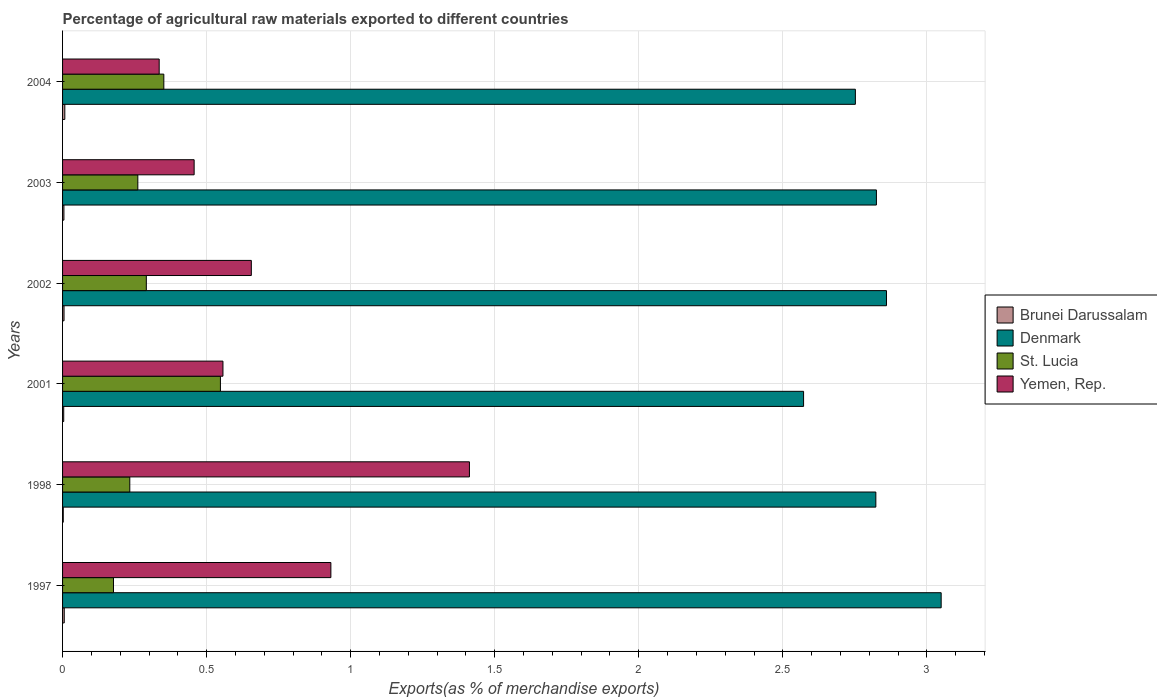How many bars are there on the 3rd tick from the top?
Offer a terse response. 4. What is the label of the 4th group of bars from the top?
Make the answer very short. 2001. In how many cases, is the number of bars for a given year not equal to the number of legend labels?
Provide a succinct answer. 0. What is the percentage of exports to different countries in Yemen, Rep. in 2001?
Your response must be concise. 0.56. Across all years, what is the maximum percentage of exports to different countries in Yemen, Rep.?
Keep it short and to the point. 1.41. Across all years, what is the minimum percentage of exports to different countries in Denmark?
Offer a terse response. 2.57. What is the total percentage of exports to different countries in St. Lucia in the graph?
Ensure brevity in your answer.  1.86. What is the difference between the percentage of exports to different countries in Yemen, Rep. in 1997 and that in 2001?
Ensure brevity in your answer.  0.37. What is the difference between the percentage of exports to different countries in Brunei Darussalam in 2004 and the percentage of exports to different countries in Yemen, Rep. in 1998?
Ensure brevity in your answer.  -1.4. What is the average percentage of exports to different countries in Denmark per year?
Give a very brief answer. 2.81. In the year 2001, what is the difference between the percentage of exports to different countries in Yemen, Rep. and percentage of exports to different countries in St. Lucia?
Offer a terse response. 0.01. What is the ratio of the percentage of exports to different countries in Yemen, Rep. in 2001 to that in 2003?
Give a very brief answer. 1.22. Is the difference between the percentage of exports to different countries in Yemen, Rep. in 1998 and 2003 greater than the difference between the percentage of exports to different countries in St. Lucia in 1998 and 2003?
Your response must be concise. Yes. What is the difference between the highest and the second highest percentage of exports to different countries in Brunei Darussalam?
Offer a terse response. 0. What is the difference between the highest and the lowest percentage of exports to different countries in St. Lucia?
Make the answer very short. 0.37. In how many years, is the percentage of exports to different countries in Denmark greater than the average percentage of exports to different countries in Denmark taken over all years?
Your answer should be very brief. 4. Is it the case that in every year, the sum of the percentage of exports to different countries in Yemen, Rep. and percentage of exports to different countries in Brunei Darussalam is greater than the sum of percentage of exports to different countries in Denmark and percentage of exports to different countries in St. Lucia?
Your answer should be compact. No. What does the 2nd bar from the top in 2004 represents?
Your answer should be compact. St. Lucia. What does the 3rd bar from the bottom in 2003 represents?
Your response must be concise. St. Lucia. Is it the case that in every year, the sum of the percentage of exports to different countries in St. Lucia and percentage of exports to different countries in Denmark is greater than the percentage of exports to different countries in Yemen, Rep.?
Offer a terse response. Yes. Are all the bars in the graph horizontal?
Offer a terse response. Yes. How many years are there in the graph?
Your answer should be compact. 6. Are the values on the major ticks of X-axis written in scientific E-notation?
Your answer should be compact. No. What is the title of the graph?
Offer a very short reply. Percentage of agricultural raw materials exported to different countries. What is the label or title of the X-axis?
Provide a short and direct response. Exports(as % of merchandise exports). What is the label or title of the Y-axis?
Offer a very short reply. Years. What is the Exports(as % of merchandise exports) in Brunei Darussalam in 1997?
Offer a very short reply. 0.01. What is the Exports(as % of merchandise exports) in Denmark in 1997?
Provide a succinct answer. 3.05. What is the Exports(as % of merchandise exports) in St. Lucia in 1997?
Make the answer very short. 0.18. What is the Exports(as % of merchandise exports) in Yemen, Rep. in 1997?
Ensure brevity in your answer.  0.93. What is the Exports(as % of merchandise exports) in Brunei Darussalam in 1998?
Offer a very short reply. 0. What is the Exports(as % of merchandise exports) in Denmark in 1998?
Provide a succinct answer. 2.82. What is the Exports(as % of merchandise exports) in St. Lucia in 1998?
Ensure brevity in your answer.  0.23. What is the Exports(as % of merchandise exports) of Yemen, Rep. in 1998?
Offer a very short reply. 1.41. What is the Exports(as % of merchandise exports) of Brunei Darussalam in 2001?
Provide a short and direct response. 0. What is the Exports(as % of merchandise exports) in Denmark in 2001?
Your answer should be compact. 2.57. What is the Exports(as % of merchandise exports) in St. Lucia in 2001?
Your answer should be very brief. 0.55. What is the Exports(as % of merchandise exports) of Yemen, Rep. in 2001?
Your answer should be compact. 0.56. What is the Exports(as % of merchandise exports) of Brunei Darussalam in 2002?
Ensure brevity in your answer.  0.01. What is the Exports(as % of merchandise exports) in Denmark in 2002?
Your answer should be compact. 2.86. What is the Exports(as % of merchandise exports) of St. Lucia in 2002?
Offer a terse response. 0.29. What is the Exports(as % of merchandise exports) in Yemen, Rep. in 2002?
Give a very brief answer. 0.66. What is the Exports(as % of merchandise exports) of Brunei Darussalam in 2003?
Provide a short and direct response. 0. What is the Exports(as % of merchandise exports) in Denmark in 2003?
Your answer should be compact. 2.82. What is the Exports(as % of merchandise exports) in St. Lucia in 2003?
Your answer should be very brief. 0.26. What is the Exports(as % of merchandise exports) in Yemen, Rep. in 2003?
Provide a short and direct response. 0.46. What is the Exports(as % of merchandise exports) of Brunei Darussalam in 2004?
Offer a terse response. 0.01. What is the Exports(as % of merchandise exports) in Denmark in 2004?
Your response must be concise. 2.75. What is the Exports(as % of merchandise exports) of St. Lucia in 2004?
Your response must be concise. 0.35. What is the Exports(as % of merchandise exports) in Yemen, Rep. in 2004?
Provide a short and direct response. 0.34. Across all years, what is the maximum Exports(as % of merchandise exports) of Brunei Darussalam?
Provide a succinct answer. 0.01. Across all years, what is the maximum Exports(as % of merchandise exports) of Denmark?
Your answer should be very brief. 3.05. Across all years, what is the maximum Exports(as % of merchandise exports) of St. Lucia?
Your answer should be very brief. 0.55. Across all years, what is the maximum Exports(as % of merchandise exports) of Yemen, Rep.?
Keep it short and to the point. 1.41. Across all years, what is the minimum Exports(as % of merchandise exports) of Brunei Darussalam?
Provide a short and direct response. 0. Across all years, what is the minimum Exports(as % of merchandise exports) of Denmark?
Offer a terse response. 2.57. Across all years, what is the minimum Exports(as % of merchandise exports) of St. Lucia?
Make the answer very short. 0.18. Across all years, what is the minimum Exports(as % of merchandise exports) in Yemen, Rep.?
Your response must be concise. 0.34. What is the total Exports(as % of merchandise exports) of Brunei Darussalam in the graph?
Offer a terse response. 0.03. What is the total Exports(as % of merchandise exports) in Denmark in the graph?
Make the answer very short. 16.88. What is the total Exports(as % of merchandise exports) of St. Lucia in the graph?
Provide a succinct answer. 1.86. What is the total Exports(as % of merchandise exports) of Yemen, Rep. in the graph?
Offer a very short reply. 4.35. What is the difference between the Exports(as % of merchandise exports) of Brunei Darussalam in 1997 and that in 1998?
Offer a very short reply. 0. What is the difference between the Exports(as % of merchandise exports) in Denmark in 1997 and that in 1998?
Provide a short and direct response. 0.23. What is the difference between the Exports(as % of merchandise exports) in St. Lucia in 1997 and that in 1998?
Your answer should be compact. -0.06. What is the difference between the Exports(as % of merchandise exports) in Yemen, Rep. in 1997 and that in 1998?
Make the answer very short. -0.48. What is the difference between the Exports(as % of merchandise exports) of Brunei Darussalam in 1997 and that in 2001?
Offer a very short reply. 0. What is the difference between the Exports(as % of merchandise exports) of Denmark in 1997 and that in 2001?
Ensure brevity in your answer.  0.48. What is the difference between the Exports(as % of merchandise exports) in St. Lucia in 1997 and that in 2001?
Ensure brevity in your answer.  -0.37. What is the difference between the Exports(as % of merchandise exports) in Yemen, Rep. in 1997 and that in 2001?
Give a very brief answer. 0.37. What is the difference between the Exports(as % of merchandise exports) in Brunei Darussalam in 1997 and that in 2002?
Your response must be concise. 0. What is the difference between the Exports(as % of merchandise exports) of Denmark in 1997 and that in 2002?
Your answer should be compact. 0.19. What is the difference between the Exports(as % of merchandise exports) in St. Lucia in 1997 and that in 2002?
Your answer should be compact. -0.11. What is the difference between the Exports(as % of merchandise exports) in Yemen, Rep. in 1997 and that in 2002?
Offer a very short reply. 0.28. What is the difference between the Exports(as % of merchandise exports) of Brunei Darussalam in 1997 and that in 2003?
Ensure brevity in your answer.  0. What is the difference between the Exports(as % of merchandise exports) in Denmark in 1997 and that in 2003?
Your response must be concise. 0.22. What is the difference between the Exports(as % of merchandise exports) of St. Lucia in 1997 and that in 2003?
Offer a terse response. -0.08. What is the difference between the Exports(as % of merchandise exports) in Yemen, Rep. in 1997 and that in 2003?
Make the answer very short. 0.47. What is the difference between the Exports(as % of merchandise exports) of Brunei Darussalam in 1997 and that in 2004?
Provide a succinct answer. -0. What is the difference between the Exports(as % of merchandise exports) in Denmark in 1997 and that in 2004?
Make the answer very short. 0.3. What is the difference between the Exports(as % of merchandise exports) of St. Lucia in 1997 and that in 2004?
Offer a terse response. -0.17. What is the difference between the Exports(as % of merchandise exports) of Yemen, Rep. in 1997 and that in 2004?
Your answer should be very brief. 0.6. What is the difference between the Exports(as % of merchandise exports) of Brunei Darussalam in 1998 and that in 2001?
Keep it short and to the point. -0. What is the difference between the Exports(as % of merchandise exports) of Denmark in 1998 and that in 2001?
Keep it short and to the point. 0.25. What is the difference between the Exports(as % of merchandise exports) of St. Lucia in 1998 and that in 2001?
Your answer should be very brief. -0.31. What is the difference between the Exports(as % of merchandise exports) in Yemen, Rep. in 1998 and that in 2001?
Your answer should be very brief. 0.86. What is the difference between the Exports(as % of merchandise exports) in Brunei Darussalam in 1998 and that in 2002?
Your answer should be very brief. -0. What is the difference between the Exports(as % of merchandise exports) of Denmark in 1998 and that in 2002?
Provide a succinct answer. -0.04. What is the difference between the Exports(as % of merchandise exports) in St. Lucia in 1998 and that in 2002?
Offer a very short reply. -0.06. What is the difference between the Exports(as % of merchandise exports) of Yemen, Rep. in 1998 and that in 2002?
Provide a short and direct response. 0.76. What is the difference between the Exports(as % of merchandise exports) in Brunei Darussalam in 1998 and that in 2003?
Your answer should be compact. -0. What is the difference between the Exports(as % of merchandise exports) of Denmark in 1998 and that in 2003?
Ensure brevity in your answer.  -0. What is the difference between the Exports(as % of merchandise exports) of St. Lucia in 1998 and that in 2003?
Provide a short and direct response. -0.03. What is the difference between the Exports(as % of merchandise exports) of Yemen, Rep. in 1998 and that in 2003?
Your response must be concise. 0.96. What is the difference between the Exports(as % of merchandise exports) in Brunei Darussalam in 1998 and that in 2004?
Your response must be concise. -0.01. What is the difference between the Exports(as % of merchandise exports) in Denmark in 1998 and that in 2004?
Keep it short and to the point. 0.07. What is the difference between the Exports(as % of merchandise exports) in St. Lucia in 1998 and that in 2004?
Ensure brevity in your answer.  -0.12. What is the difference between the Exports(as % of merchandise exports) of Brunei Darussalam in 2001 and that in 2002?
Offer a very short reply. -0. What is the difference between the Exports(as % of merchandise exports) of Denmark in 2001 and that in 2002?
Provide a succinct answer. -0.29. What is the difference between the Exports(as % of merchandise exports) of St. Lucia in 2001 and that in 2002?
Offer a very short reply. 0.26. What is the difference between the Exports(as % of merchandise exports) of Yemen, Rep. in 2001 and that in 2002?
Provide a short and direct response. -0.1. What is the difference between the Exports(as % of merchandise exports) of Brunei Darussalam in 2001 and that in 2003?
Your answer should be very brief. -0. What is the difference between the Exports(as % of merchandise exports) in Denmark in 2001 and that in 2003?
Your response must be concise. -0.25. What is the difference between the Exports(as % of merchandise exports) in St. Lucia in 2001 and that in 2003?
Make the answer very short. 0.29. What is the difference between the Exports(as % of merchandise exports) in Yemen, Rep. in 2001 and that in 2003?
Keep it short and to the point. 0.1. What is the difference between the Exports(as % of merchandise exports) of Brunei Darussalam in 2001 and that in 2004?
Offer a very short reply. -0. What is the difference between the Exports(as % of merchandise exports) of Denmark in 2001 and that in 2004?
Ensure brevity in your answer.  -0.18. What is the difference between the Exports(as % of merchandise exports) in St. Lucia in 2001 and that in 2004?
Your answer should be very brief. 0.2. What is the difference between the Exports(as % of merchandise exports) of Yemen, Rep. in 2001 and that in 2004?
Make the answer very short. 0.22. What is the difference between the Exports(as % of merchandise exports) of Denmark in 2002 and that in 2003?
Your answer should be compact. 0.03. What is the difference between the Exports(as % of merchandise exports) of St. Lucia in 2002 and that in 2003?
Ensure brevity in your answer.  0.03. What is the difference between the Exports(as % of merchandise exports) in Yemen, Rep. in 2002 and that in 2003?
Provide a succinct answer. 0.2. What is the difference between the Exports(as % of merchandise exports) in Brunei Darussalam in 2002 and that in 2004?
Your answer should be compact. -0. What is the difference between the Exports(as % of merchandise exports) of Denmark in 2002 and that in 2004?
Your answer should be very brief. 0.11. What is the difference between the Exports(as % of merchandise exports) of St. Lucia in 2002 and that in 2004?
Provide a short and direct response. -0.06. What is the difference between the Exports(as % of merchandise exports) in Yemen, Rep. in 2002 and that in 2004?
Offer a terse response. 0.32. What is the difference between the Exports(as % of merchandise exports) of Brunei Darussalam in 2003 and that in 2004?
Offer a terse response. -0. What is the difference between the Exports(as % of merchandise exports) of Denmark in 2003 and that in 2004?
Your response must be concise. 0.07. What is the difference between the Exports(as % of merchandise exports) in St. Lucia in 2003 and that in 2004?
Keep it short and to the point. -0.09. What is the difference between the Exports(as % of merchandise exports) of Yemen, Rep. in 2003 and that in 2004?
Your answer should be compact. 0.12. What is the difference between the Exports(as % of merchandise exports) in Brunei Darussalam in 1997 and the Exports(as % of merchandise exports) in Denmark in 1998?
Give a very brief answer. -2.82. What is the difference between the Exports(as % of merchandise exports) of Brunei Darussalam in 1997 and the Exports(as % of merchandise exports) of St. Lucia in 1998?
Offer a terse response. -0.23. What is the difference between the Exports(as % of merchandise exports) in Brunei Darussalam in 1997 and the Exports(as % of merchandise exports) in Yemen, Rep. in 1998?
Your answer should be compact. -1.41. What is the difference between the Exports(as % of merchandise exports) of Denmark in 1997 and the Exports(as % of merchandise exports) of St. Lucia in 1998?
Offer a terse response. 2.82. What is the difference between the Exports(as % of merchandise exports) of Denmark in 1997 and the Exports(as % of merchandise exports) of Yemen, Rep. in 1998?
Your answer should be compact. 1.64. What is the difference between the Exports(as % of merchandise exports) of St. Lucia in 1997 and the Exports(as % of merchandise exports) of Yemen, Rep. in 1998?
Your answer should be compact. -1.24. What is the difference between the Exports(as % of merchandise exports) in Brunei Darussalam in 1997 and the Exports(as % of merchandise exports) in Denmark in 2001?
Make the answer very short. -2.57. What is the difference between the Exports(as % of merchandise exports) of Brunei Darussalam in 1997 and the Exports(as % of merchandise exports) of St. Lucia in 2001?
Ensure brevity in your answer.  -0.54. What is the difference between the Exports(as % of merchandise exports) of Brunei Darussalam in 1997 and the Exports(as % of merchandise exports) of Yemen, Rep. in 2001?
Ensure brevity in your answer.  -0.55. What is the difference between the Exports(as % of merchandise exports) of Denmark in 1997 and the Exports(as % of merchandise exports) of St. Lucia in 2001?
Your answer should be very brief. 2.5. What is the difference between the Exports(as % of merchandise exports) in Denmark in 1997 and the Exports(as % of merchandise exports) in Yemen, Rep. in 2001?
Ensure brevity in your answer.  2.49. What is the difference between the Exports(as % of merchandise exports) of St. Lucia in 1997 and the Exports(as % of merchandise exports) of Yemen, Rep. in 2001?
Provide a succinct answer. -0.38. What is the difference between the Exports(as % of merchandise exports) in Brunei Darussalam in 1997 and the Exports(as % of merchandise exports) in Denmark in 2002?
Provide a short and direct response. -2.85. What is the difference between the Exports(as % of merchandise exports) of Brunei Darussalam in 1997 and the Exports(as % of merchandise exports) of St. Lucia in 2002?
Give a very brief answer. -0.28. What is the difference between the Exports(as % of merchandise exports) of Brunei Darussalam in 1997 and the Exports(as % of merchandise exports) of Yemen, Rep. in 2002?
Ensure brevity in your answer.  -0.65. What is the difference between the Exports(as % of merchandise exports) in Denmark in 1997 and the Exports(as % of merchandise exports) in St. Lucia in 2002?
Ensure brevity in your answer.  2.76. What is the difference between the Exports(as % of merchandise exports) in Denmark in 1997 and the Exports(as % of merchandise exports) in Yemen, Rep. in 2002?
Offer a terse response. 2.39. What is the difference between the Exports(as % of merchandise exports) in St. Lucia in 1997 and the Exports(as % of merchandise exports) in Yemen, Rep. in 2002?
Provide a succinct answer. -0.48. What is the difference between the Exports(as % of merchandise exports) in Brunei Darussalam in 1997 and the Exports(as % of merchandise exports) in Denmark in 2003?
Offer a terse response. -2.82. What is the difference between the Exports(as % of merchandise exports) of Brunei Darussalam in 1997 and the Exports(as % of merchandise exports) of St. Lucia in 2003?
Offer a very short reply. -0.26. What is the difference between the Exports(as % of merchandise exports) of Brunei Darussalam in 1997 and the Exports(as % of merchandise exports) of Yemen, Rep. in 2003?
Give a very brief answer. -0.45. What is the difference between the Exports(as % of merchandise exports) in Denmark in 1997 and the Exports(as % of merchandise exports) in St. Lucia in 2003?
Offer a very short reply. 2.79. What is the difference between the Exports(as % of merchandise exports) in Denmark in 1997 and the Exports(as % of merchandise exports) in Yemen, Rep. in 2003?
Your answer should be compact. 2.59. What is the difference between the Exports(as % of merchandise exports) in St. Lucia in 1997 and the Exports(as % of merchandise exports) in Yemen, Rep. in 2003?
Give a very brief answer. -0.28. What is the difference between the Exports(as % of merchandise exports) in Brunei Darussalam in 1997 and the Exports(as % of merchandise exports) in Denmark in 2004?
Keep it short and to the point. -2.75. What is the difference between the Exports(as % of merchandise exports) in Brunei Darussalam in 1997 and the Exports(as % of merchandise exports) in St. Lucia in 2004?
Your answer should be very brief. -0.35. What is the difference between the Exports(as % of merchandise exports) in Brunei Darussalam in 1997 and the Exports(as % of merchandise exports) in Yemen, Rep. in 2004?
Offer a terse response. -0.33. What is the difference between the Exports(as % of merchandise exports) of Denmark in 1997 and the Exports(as % of merchandise exports) of St. Lucia in 2004?
Provide a succinct answer. 2.7. What is the difference between the Exports(as % of merchandise exports) of Denmark in 1997 and the Exports(as % of merchandise exports) of Yemen, Rep. in 2004?
Make the answer very short. 2.71. What is the difference between the Exports(as % of merchandise exports) of St. Lucia in 1997 and the Exports(as % of merchandise exports) of Yemen, Rep. in 2004?
Your answer should be very brief. -0.16. What is the difference between the Exports(as % of merchandise exports) in Brunei Darussalam in 1998 and the Exports(as % of merchandise exports) in Denmark in 2001?
Provide a short and direct response. -2.57. What is the difference between the Exports(as % of merchandise exports) in Brunei Darussalam in 1998 and the Exports(as % of merchandise exports) in St. Lucia in 2001?
Offer a terse response. -0.55. What is the difference between the Exports(as % of merchandise exports) of Brunei Darussalam in 1998 and the Exports(as % of merchandise exports) of Yemen, Rep. in 2001?
Provide a succinct answer. -0.55. What is the difference between the Exports(as % of merchandise exports) of Denmark in 1998 and the Exports(as % of merchandise exports) of St. Lucia in 2001?
Ensure brevity in your answer.  2.27. What is the difference between the Exports(as % of merchandise exports) of Denmark in 1998 and the Exports(as % of merchandise exports) of Yemen, Rep. in 2001?
Offer a very short reply. 2.27. What is the difference between the Exports(as % of merchandise exports) of St. Lucia in 1998 and the Exports(as % of merchandise exports) of Yemen, Rep. in 2001?
Your response must be concise. -0.32. What is the difference between the Exports(as % of merchandise exports) in Brunei Darussalam in 1998 and the Exports(as % of merchandise exports) in Denmark in 2002?
Provide a succinct answer. -2.86. What is the difference between the Exports(as % of merchandise exports) of Brunei Darussalam in 1998 and the Exports(as % of merchandise exports) of St. Lucia in 2002?
Keep it short and to the point. -0.29. What is the difference between the Exports(as % of merchandise exports) of Brunei Darussalam in 1998 and the Exports(as % of merchandise exports) of Yemen, Rep. in 2002?
Give a very brief answer. -0.65. What is the difference between the Exports(as % of merchandise exports) of Denmark in 1998 and the Exports(as % of merchandise exports) of St. Lucia in 2002?
Your answer should be very brief. 2.53. What is the difference between the Exports(as % of merchandise exports) of Denmark in 1998 and the Exports(as % of merchandise exports) of Yemen, Rep. in 2002?
Offer a very short reply. 2.17. What is the difference between the Exports(as % of merchandise exports) in St. Lucia in 1998 and the Exports(as % of merchandise exports) in Yemen, Rep. in 2002?
Your answer should be very brief. -0.42. What is the difference between the Exports(as % of merchandise exports) in Brunei Darussalam in 1998 and the Exports(as % of merchandise exports) in Denmark in 2003?
Provide a succinct answer. -2.82. What is the difference between the Exports(as % of merchandise exports) in Brunei Darussalam in 1998 and the Exports(as % of merchandise exports) in St. Lucia in 2003?
Offer a terse response. -0.26. What is the difference between the Exports(as % of merchandise exports) in Brunei Darussalam in 1998 and the Exports(as % of merchandise exports) in Yemen, Rep. in 2003?
Make the answer very short. -0.45. What is the difference between the Exports(as % of merchandise exports) of Denmark in 1998 and the Exports(as % of merchandise exports) of St. Lucia in 2003?
Your response must be concise. 2.56. What is the difference between the Exports(as % of merchandise exports) in Denmark in 1998 and the Exports(as % of merchandise exports) in Yemen, Rep. in 2003?
Keep it short and to the point. 2.37. What is the difference between the Exports(as % of merchandise exports) of St. Lucia in 1998 and the Exports(as % of merchandise exports) of Yemen, Rep. in 2003?
Your answer should be very brief. -0.22. What is the difference between the Exports(as % of merchandise exports) of Brunei Darussalam in 1998 and the Exports(as % of merchandise exports) of Denmark in 2004?
Keep it short and to the point. -2.75. What is the difference between the Exports(as % of merchandise exports) of Brunei Darussalam in 1998 and the Exports(as % of merchandise exports) of St. Lucia in 2004?
Offer a terse response. -0.35. What is the difference between the Exports(as % of merchandise exports) in Brunei Darussalam in 1998 and the Exports(as % of merchandise exports) in Yemen, Rep. in 2004?
Your answer should be very brief. -0.33. What is the difference between the Exports(as % of merchandise exports) in Denmark in 1998 and the Exports(as % of merchandise exports) in St. Lucia in 2004?
Give a very brief answer. 2.47. What is the difference between the Exports(as % of merchandise exports) in Denmark in 1998 and the Exports(as % of merchandise exports) in Yemen, Rep. in 2004?
Offer a very short reply. 2.49. What is the difference between the Exports(as % of merchandise exports) of St. Lucia in 1998 and the Exports(as % of merchandise exports) of Yemen, Rep. in 2004?
Your answer should be very brief. -0.1. What is the difference between the Exports(as % of merchandise exports) of Brunei Darussalam in 2001 and the Exports(as % of merchandise exports) of Denmark in 2002?
Make the answer very short. -2.86. What is the difference between the Exports(as % of merchandise exports) in Brunei Darussalam in 2001 and the Exports(as % of merchandise exports) in St. Lucia in 2002?
Give a very brief answer. -0.29. What is the difference between the Exports(as % of merchandise exports) of Brunei Darussalam in 2001 and the Exports(as % of merchandise exports) of Yemen, Rep. in 2002?
Keep it short and to the point. -0.65. What is the difference between the Exports(as % of merchandise exports) in Denmark in 2001 and the Exports(as % of merchandise exports) in St. Lucia in 2002?
Give a very brief answer. 2.28. What is the difference between the Exports(as % of merchandise exports) of Denmark in 2001 and the Exports(as % of merchandise exports) of Yemen, Rep. in 2002?
Keep it short and to the point. 1.92. What is the difference between the Exports(as % of merchandise exports) of St. Lucia in 2001 and the Exports(as % of merchandise exports) of Yemen, Rep. in 2002?
Provide a short and direct response. -0.11. What is the difference between the Exports(as % of merchandise exports) of Brunei Darussalam in 2001 and the Exports(as % of merchandise exports) of Denmark in 2003?
Make the answer very short. -2.82. What is the difference between the Exports(as % of merchandise exports) of Brunei Darussalam in 2001 and the Exports(as % of merchandise exports) of St. Lucia in 2003?
Make the answer very short. -0.26. What is the difference between the Exports(as % of merchandise exports) of Brunei Darussalam in 2001 and the Exports(as % of merchandise exports) of Yemen, Rep. in 2003?
Offer a terse response. -0.45. What is the difference between the Exports(as % of merchandise exports) in Denmark in 2001 and the Exports(as % of merchandise exports) in St. Lucia in 2003?
Your answer should be very brief. 2.31. What is the difference between the Exports(as % of merchandise exports) in Denmark in 2001 and the Exports(as % of merchandise exports) in Yemen, Rep. in 2003?
Make the answer very short. 2.12. What is the difference between the Exports(as % of merchandise exports) of St. Lucia in 2001 and the Exports(as % of merchandise exports) of Yemen, Rep. in 2003?
Provide a short and direct response. 0.09. What is the difference between the Exports(as % of merchandise exports) of Brunei Darussalam in 2001 and the Exports(as % of merchandise exports) of Denmark in 2004?
Offer a terse response. -2.75. What is the difference between the Exports(as % of merchandise exports) in Brunei Darussalam in 2001 and the Exports(as % of merchandise exports) in St. Lucia in 2004?
Ensure brevity in your answer.  -0.35. What is the difference between the Exports(as % of merchandise exports) of Brunei Darussalam in 2001 and the Exports(as % of merchandise exports) of Yemen, Rep. in 2004?
Your answer should be compact. -0.33. What is the difference between the Exports(as % of merchandise exports) in Denmark in 2001 and the Exports(as % of merchandise exports) in St. Lucia in 2004?
Your answer should be very brief. 2.22. What is the difference between the Exports(as % of merchandise exports) in Denmark in 2001 and the Exports(as % of merchandise exports) in Yemen, Rep. in 2004?
Your answer should be very brief. 2.24. What is the difference between the Exports(as % of merchandise exports) of St. Lucia in 2001 and the Exports(as % of merchandise exports) of Yemen, Rep. in 2004?
Ensure brevity in your answer.  0.21. What is the difference between the Exports(as % of merchandise exports) in Brunei Darussalam in 2002 and the Exports(as % of merchandise exports) in Denmark in 2003?
Your answer should be very brief. -2.82. What is the difference between the Exports(as % of merchandise exports) in Brunei Darussalam in 2002 and the Exports(as % of merchandise exports) in St. Lucia in 2003?
Provide a succinct answer. -0.26. What is the difference between the Exports(as % of merchandise exports) in Brunei Darussalam in 2002 and the Exports(as % of merchandise exports) in Yemen, Rep. in 2003?
Provide a succinct answer. -0.45. What is the difference between the Exports(as % of merchandise exports) in Denmark in 2002 and the Exports(as % of merchandise exports) in St. Lucia in 2003?
Give a very brief answer. 2.6. What is the difference between the Exports(as % of merchandise exports) of Denmark in 2002 and the Exports(as % of merchandise exports) of Yemen, Rep. in 2003?
Your response must be concise. 2.4. What is the difference between the Exports(as % of merchandise exports) in St. Lucia in 2002 and the Exports(as % of merchandise exports) in Yemen, Rep. in 2003?
Give a very brief answer. -0.17. What is the difference between the Exports(as % of merchandise exports) of Brunei Darussalam in 2002 and the Exports(as % of merchandise exports) of Denmark in 2004?
Provide a succinct answer. -2.75. What is the difference between the Exports(as % of merchandise exports) in Brunei Darussalam in 2002 and the Exports(as % of merchandise exports) in St. Lucia in 2004?
Provide a short and direct response. -0.35. What is the difference between the Exports(as % of merchandise exports) in Brunei Darussalam in 2002 and the Exports(as % of merchandise exports) in Yemen, Rep. in 2004?
Offer a very short reply. -0.33. What is the difference between the Exports(as % of merchandise exports) in Denmark in 2002 and the Exports(as % of merchandise exports) in St. Lucia in 2004?
Your answer should be compact. 2.51. What is the difference between the Exports(as % of merchandise exports) in Denmark in 2002 and the Exports(as % of merchandise exports) in Yemen, Rep. in 2004?
Give a very brief answer. 2.52. What is the difference between the Exports(as % of merchandise exports) in St. Lucia in 2002 and the Exports(as % of merchandise exports) in Yemen, Rep. in 2004?
Make the answer very short. -0.04. What is the difference between the Exports(as % of merchandise exports) of Brunei Darussalam in 2003 and the Exports(as % of merchandise exports) of Denmark in 2004?
Offer a very short reply. -2.75. What is the difference between the Exports(as % of merchandise exports) in Brunei Darussalam in 2003 and the Exports(as % of merchandise exports) in St. Lucia in 2004?
Ensure brevity in your answer.  -0.35. What is the difference between the Exports(as % of merchandise exports) of Brunei Darussalam in 2003 and the Exports(as % of merchandise exports) of Yemen, Rep. in 2004?
Ensure brevity in your answer.  -0.33. What is the difference between the Exports(as % of merchandise exports) in Denmark in 2003 and the Exports(as % of merchandise exports) in St. Lucia in 2004?
Your answer should be very brief. 2.47. What is the difference between the Exports(as % of merchandise exports) in Denmark in 2003 and the Exports(as % of merchandise exports) in Yemen, Rep. in 2004?
Offer a very short reply. 2.49. What is the difference between the Exports(as % of merchandise exports) in St. Lucia in 2003 and the Exports(as % of merchandise exports) in Yemen, Rep. in 2004?
Provide a short and direct response. -0.07. What is the average Exports(as % of merchandise exports) in Brunei Darussalam per year?
Make the answer very short. 0.01. What is the average Exports(as % of merchandise exports) in Denmark per year?
Give a very brief answer. 2.81. What is the average Exports(as % of merchandise exports) of St. Lucia per year?
Provide a short and direct response. 0.31. What is the average Exports(as % of merchandise exports) in Yemen, Rep. per year?
Provide a short and direct response. 0.72. In the year 1997, what is the difference between the Exports(as % of merchandise exports) of Brunei Darussalam and Exports(as % of merchandise exports) of Denmark?
Offer a very short reply. -3.04. In the year 1997, what is the difference between the Exports(as % of merchandise exports) in Brunei Darussalam and Exports(as % of merchandise exports) in St. Lucia?
Provide a short and direct response. -0.17. In the year 1997, what is the difference between the Exports(as % of merchandise exports) of Brunei Darussalam and Exports(as % of merchandise exports) of Yemen, Rep.?
Provide a succinct answer. -0.93. In the year 1997, what is the difference between the Exports(as % of merchandise exports) in Denmark and Exports(as % of merchandise exports) in St. Lucia?
Give a very brief answer. 2.87. In the year 1997, what is the difference between the Exports(as % of merchandise exports) of Denmark and Exports(as % of merchandise exports) of Yemen, Rep.?
Ensure brevity in your answer.  2.12. In the year 1997, what is the difference between the Exports(as % of merchandise exports) of St. Lucia and Exports(as % of merchandise exports) of Yemen, Rep.?
Give a very brief answer. -0.75. In the year 1998, what is the difference between the Exports(as % of merchandise exports) of Brunei Darussalam and Exports(as % of merchandise exports) of Denmark?
Your response must be concise. -2.82. In the year 1998, what is the difference between the Exports(as % of merchandise exports) of Brunei Darussalam and Exports(as % of merchandise exports) of St. Lucia?
Provide a succinct answer. -0.23. In the year 1998, what is the difference between the Exports(as % of merchandise exports) in Brunei Darussalam and Exports(as % of merchandise exports) in Yemen, Rep.?
Ensure brevity in your answer.  -1.41. In the year 1998, what is the difference between the Exports(as % of merchandise exports) of Denmark and Exports(as % of merchandise exports) of St. Lucia?
Provide a succinct answer. 2.59. In the year 1998, what is the difference between the Exports(as % of merchandise exports) of Denmark and Exports(as % of merchandise exports) of Yemen, Rep.?
Offer a very short reply. 1.41. In the year 1998, what is the difference between the Exports(as % of merchandise exports) in St. Lucia and Exports(as % of merchandise exports) in Yemen, Rep.?
Give a very brief answer. -1.18. In the year 2001, what is the difference between the Exports(as % of merchandise exports) in Brunei Darussalam and Exports(as % of merchandise exports) in Denmark?
Ensure brevity in your answer.  -2.57. In the year 2001, what is the difference between the Exports(as % of merchandise exports) of Brunei Darussalam and Exports(as % of merchandise exports) of St. Lucia?
Your answer should be very brief. -0.54. In the year 2001, what is the difference between the Exports(as % of merchandise exports) of Brunei Darussalam and Exports(as % of merchandise exports) of Yemen, Rep.?
Offer a very short reply. -0.55. In the year 2001, what is the difference between the Exports(as % of merchandise exports) of Denmark and Exports(as % of merchandise exports) of St. Lucia?
Provide a short and direct response. 2.02. In the year 2001, what is the difference between the Exports(as % of merchandise exports) of Denmark and Exports(as % of merchandise exports) of Yemen, Rep.?
Ensure brevity in your answer.  2.02. In the year 2001, what is the difference between the Exports(as % of merchandise exports) in St. Lucia and Exports(as % of merchandise exports) in Yemen, Rep.?
Your answer should be very brief. -0.01. In the year 2002, what is the difference between the Exports(as % of merchandise exports) of Brunei Darussalam and Exports(as % of merchandise exports) of Denmark?
Your answer should be very brief. -2.85. In the year 2002, what is the difference between the Exports(as % of merchandise exports) in Brunei Darussalam and Exports(as % of merchandise exports) in St. Lucia?
Provide a short and direct response. -0.29. In the year 2002, what is the difference between the Exports(as % of merchandise exports) in Brunei Darussalam and Exports(as % of merchandise exports) in Yemen, Rep.?
Your answer should be compact. -0.65. In the year 2002, what is the difference between the Exports(as % of merchandise exports) in Denmark and Exports(as % of merchandise exports) in St. Lucia?
Make the answer very short. 2.57. In the year 2002, what is the difference between the Exports(as % of merchandise exports) in Denmark and Exports(as % of merchandise exports) in Yemen, Rep.?
Your response must be concise. 2.2. In the year 2002, what is the difference between the Exports(as % of merchandise exports) of St. Lucia and Exports(as % of merchandise exports) of Yemen, Rep.?
Offer a terse response. -0.36. In the year 2003, what is the difference between the Exports(as % of merchandise exports) of Brunei Darussalam and Exports(as % of merchandise exports) of Denmark?
Keep it short and to the point. -2.82. In the year 2003, what is the difference between the Exports(as % of merchandise exports) of Brunei Darussalam and Exports(as % of merchandise exports) of St. Lucia?
Offer a very short reply. -0.26. In the year 2003, what is the difference between the Exports(as % of merchandise exports) of Brunei Darussalam and Exports(as % of merchandise exports) of Yemen, Rep.?
Ensure brevity in your answer.  -0.45. In the year 2003, what is the difference between the Exports(as % of merchandise exports) of Denmark and Exports(as % of merchandise exports) of St. Lucia?
Keep it short and to the point. 2.56. In the year 2003, what is the difference between the Exports(as % of merchandise exports) of Denmark and Exports(as % of merchandise exports) of Yemen, Rep.?
Your answer should be very brief. 2.37. In the year 2003, what is the difference between the Exports(as % of merchandise exports) in St. Lucia and Exports(as % of merchandise exports) in Yemen, Rep.?
Give a very brief answer. -0.2. In the year 2004, what is the difference between the Exports(as % of merchandise exports) in Brunei Darussalam and Exports(as % of merchandise exports) in Denmark?
Provide a short and direct response. -2.74. In the year 2004, what is the difference between the Exports(as % of merchandise exports) in Brunei Darussalam and Exports(as % of merchandise exports) in St. Lucia?
Offer a terse response. -0.34. In the year 2004, what is the difference between the Exports(as % of merchandise exports) of Brunei Darussalam and Exports(as % of merchandise exports) of Yemen, Rep.?
Keep it short and to the point. -0.33. In the year 2004, what is the difference between the Exports(as % of merchandise exports) in Denmark and Exports(as % of merchandise exports) in St. Lucia?
Keep it short and to the point. 2.4. In the year 2004, what is the difference between the Exports(as % of merchandise exports) in Denmark and Exports(as % of merchandise exports) in Yemen, Rep.?
Give a very brief answer. 2.42. In the year 2004, what is the difference between the Exports(as % of merchandise exports) in St. Lucia and Exports(as % of merchandise exports) in Yemen, Rep.?
Offer a very short reply. 0.02. What is the ratio of the Exports(as % of merchandise exports) of Brunei Darussalam in 1997 to that in 1998?
Ensure brevity in your answer.  2.39. What is the ratio of the Exports(as % of merchandise exports) of Denmark in 1997 to that in 1998?
Make the answer very short. 1.08. What is the ratio of the Exports(as % of merchandise exports) in St. Lucia in 1997 to that in 1998?
Your response must be concise. 0.76. What is the ratio of the Exports(as % of merchandise exports) of Yemen, Rep. in 1997 to that in 1998?
Ensure brevity in your answer.  0.66. What is the ratio of the Exports(as % of merchandise exports) of Brunei Darussalam in 1997 to that in 2001?
Offer a very short reply. 1.45. What is the ratio of the Exports(as % of merchandise exports) in Denmark in 1997 to that in 2001?
Give a very brief answer. 1.19. What is the ratio of the Exports(as % of merchandise exports) in St. Lucia in 1997 to that in 2001?
Keep it short and to the point. 0.32. What is the ratio of the Exports(as % of merchandise exports) of Yemen, Rep. in 1997 to that in 2001?
Ensure brevity in your answer.  1.67. What is the ratio of the Exports(as % of merchandise exports) in Brunei Darussalam in 1997 to that in 2002?
Make the answer very short. 1.15. What is the ratio of the Exports(as % of merchandise exports) in Denmark in 1997 to that in 2002?
Give a very brief answer. 1.07. What is the ratio of the Exports(as % of merchandise exports) of St. Lucia in 1997 to that in 2002?
Provide a succinct answer. 0.61. What is the ratio of the Exports(as % of merchandise exports) in Yemen, Rep. in 1997 to that in 2002?
Your answer should be compact. 1.42. What is the ratio of the Exports(as % of merchandise exports) of Brunei Darussalam in 1997 to that in 2003?
Give a very brief answer. 1.24. What is the ratio of the Exports(as % of merchandise exports) in Denmark in 1997 to that in 2003?
Your answer should be compact. 1.08. What is the ratio of the Exports(as % of merchandise exports) of St. Lucia in 1997 to that in 2003?
Offer a terse response. 0.68. What is the ratio of the Exports(as % of merchandise exports) in Yemen, Rep. in 1997 to that in 2003?
Provide a short and direct response. 2.04. What is the ratio of the Exports(as % of merchandise exports) in Brunei Darussalam in 1997 to that in 2004?
Your answer should be compact. 0.75. What is the ratio of the Exports(as % of merchandise exports) in Denmark in 1997 to that in 2004?
Make the answer very short. 1.11. What is the ratio of the Exports(as % of merchandise exports) of St. Lucia in 1997 to that in 2004?
Make the answer very short. 0.5. What is the ratio of the Exports(as % of merchandise exports) in Yemen, Rep. in 1997 to that in 2004?
Provide a succinct answer. 2.78. What is the ratio of the Exports(as % of merchandise exports) of Brunei Darussalam in 1998 to that in 2001?
Make the answer very short. 0.61. What is the ratio of the Exports(as % of merchandise exports) in Denmark in 1998 to that in 2001?
Your answer should be compact. 1.1. What is the ratio of the Exports(as % of merchandise exports) of St. Lucia in 1998 to that in 2001?
Your response must be concise. 0.43. What is the ratio of the Exports(as % of merchandise exports) of Yemen, Rep. in 1998 to that in 2001?
Keep it short and to the point. 2.54. What is the ratio of the Exports(as % of merchandise exports) in Brunei Darussalam in 1998 to that in 2002?
Offer a terse response. 0.48. What is the ratio of the Exports(as % of merchandise exports) of Denmark in 1998 to that in 2002?
Keep it short and to the point. 0.99. What is the ratio of the Exports(as % of merchandise exports) in St. Lucia in 1998 to that in 2002?
Your answer should be compact. 0.8. What is the ratio of the Exports(as % of merchandise exports) in Yemen, Rep. in 1998 to that in 2002?
Your answer should be compact. 2.16. What is the ratio of the Exports(as % of merchandise exports) in Brunei Darussalam in 1998 to that in 2003?
Provide a succinct answer. 0.52. What is the ratio of the Exports(as % of merchandise exports) of Denmark in 1998 to that in 2003?
Offer a very short reply. 1. What is the ratio of the Exports(as % of merchandise exports) in St. Lucia in 1998 to that in 2003?
Your answer should be very brief. 0.89. What is the ratio of the Exports(as % of merchandise exports) of Yemen, Rep. in 1998 to that in 2003?
Make the answer very short. 3.09. What is the ratio of the Exports(as % of merchandise exports) of Brunei Darussalam in 1998 to that in 2004?
Offer a very short reply. 0.31. What is the ratio of the Exports(as % of merchandise exports) of Denmark in 1998 to that in 2004?
Offer a terse response. 1.03. What is the ratio of the Exports(as % of merchandise exports) in St. Lucia in 1998 to that in 2004?
Make the answer very short. 0.66. What is the ratio of the Exports(as % of merchandise exports) of Yemen, Rep. in 1998 to that in 2004?
Offer a very short reply. 4.21. What is the ratio of the Exports(as % of merchandise exports) of Brunei Darussalam in 2001 to that in 2002?
Your answer should be very brief. 0.79. What is the ratio of the Exports(as % of merchandise exports) of Denmark in 2001 to that in 2002?
Make the answer very short. 0.9. What is the ratio of the Exports(as % of merchandise exports) of St. Lucia in 2001 to that in 2002?
Ensure brevity in your answer.  1.88. What is the ratio of the Exports(as % of merchandise exports) of Yemen, Rep. in 2001 to that in 2002?
Give a very brief answer. 0.85. What is the ratio of the Exports(as % of merchandise exports) of Brunei Darussalam in 2001 to that in 2003?
Offer a terse response. 0.85. What is the ratio of the Exports(as % of merchandise exports) in Denmark in 2001 to that in 2003?
Offer a very short reply. 0.91. What is the ratio of the Exports(as % of merchandise exports) in St. Lucia in 2001 to that in 2003?
Give a very brief answer. 2.1. What is the ratio of the Exports(as % of merchandise exports) of Yemen, Rep. in 2001 to that in 2003?
Provide a short and direct response. 1.22. What is the ratio of the Exports(as % of merchandise exports) of Brunei Darussalam in 2001 to that in 2004?
Ensure brevity in your answer.  0.52. What is the ratio of the Exports(as % of merchandise exports) in Denmark in 2001 to that in 2004?
Keep it short and to the point. 0.93. What is the ratio of the Exports(as % of merchandise exports) of St. Lucia in 2001 to that in 2004?
Ensure brevity in your answer.  1.56. What is the ratio of the Exports(as % of merchandise exports) of Yemen, Rep. in 2001 to that in 2004?
Your response must be concise. 1.66. What is the ratio of the Exports(as % of merchandise exports) in Brunei Darussalam in 2002 to that in 2003?
Make the answer very short. 1.08. What is the ratio of the Exports(as % of merchandise exports) of Denmark in 2002 to that in 2003?
Offer a very short reply. 1.01. What is the ratio of the Exports(as % of merchandise exports) of St. Lucia in 2002 to that in 2003?
Ensure brevity in your answer.  1.11. What is the ratio of the Exports(as % of merchandise exports) in Yemen, Rep. in 2002 to that in 2003?
Make the answer very short. 1.43. What is the ratio of the Exports(as % of merchandise exports) of Brunei Darussalam in 2002 to that in 2004?
Your answer should be compact. 0.66. What is the ratio of the Exports(as % of merchandise exports) in Denmark in 2002 to that in 2004?
Your answer should be compact. 1.04. What is the ratio of the Exports(as % of merchandise exports) in St. Lucia in 2002 to that in 2004?
Provide a succinct answer. 0.83. What is the ratio of the Exports(as % of merchandise exports) of Yemen, Rep. in 2002 to that in 2004?
Your answer should be very brief. 1.95. What is the ratio of the Exports(as % of merchandise exports) in Brunei Darussalam in 2003 to that in 2004?
Your response must be concise. 0.61. What is the ratio of the Exports(as % of merchandise exports) in Denmark in 2003 to that in 2004?
Your answer should be compact. 1.03. What is the ratio of the Exports(as % of merchandise exports) of St. Lucia in 2003 to that in 2004?
Make the answer very short. 0.74. What is the ratio of the Exports(as % of merchandise exports) of Yemen, Rep. in 2003 to that in 2004?
Offer a very short reply. 1.36. What is the difference between the highest and the second highest Exports(as % of merchandise exports) of Brunei Darussalam?
Offer a very short reply. 0. What is the difference between the highest and the second highest Exports(as % of merchandise exports) of Denmark?
Offer a very short reply. 0.19. What is the difference between the highest and the second highest Exports(as % of merchandise exports) of St. Lucia?
Provide a short and direct response. 0.2. What is the difference between the highest and the second highest Exports(as % of merchandise exports) in Yemen, Rep.?
Offer a terse response. 0.48. What is the difference between the highest and the lowest Exports(as % of merchandise exports) in Brunei Darussalam?
Provide a short and direct response. 0.01. What is the difference between the highest and the lowest Exports(as % of merchandise exports) of Denmark?
Offer a terse response. 0.48. What is the difference between the highest and the lowest Exports(as % of merchandise exports) of St. Lucia?
Give a very brief answer. 0.37. 